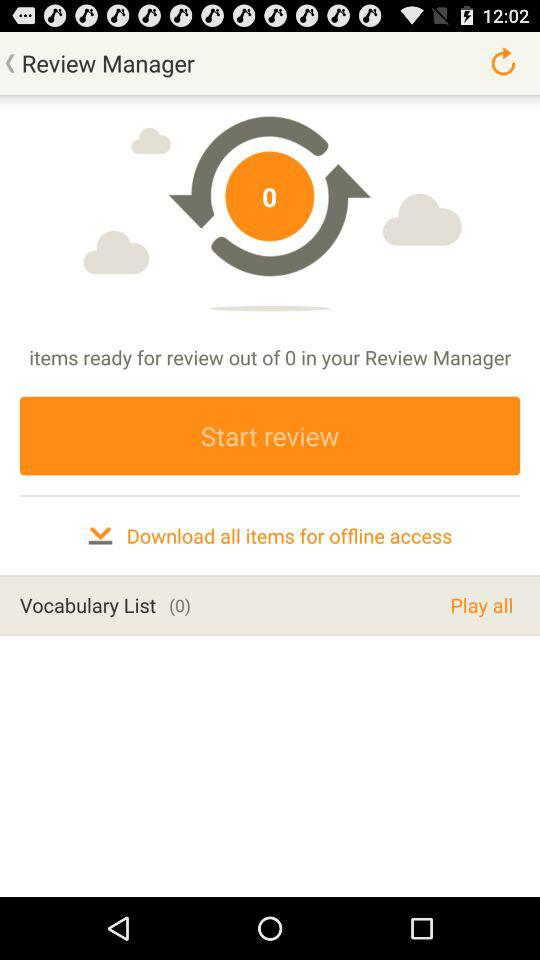How many items are ready for review?
Answer the question using a single word or phrase. 0 